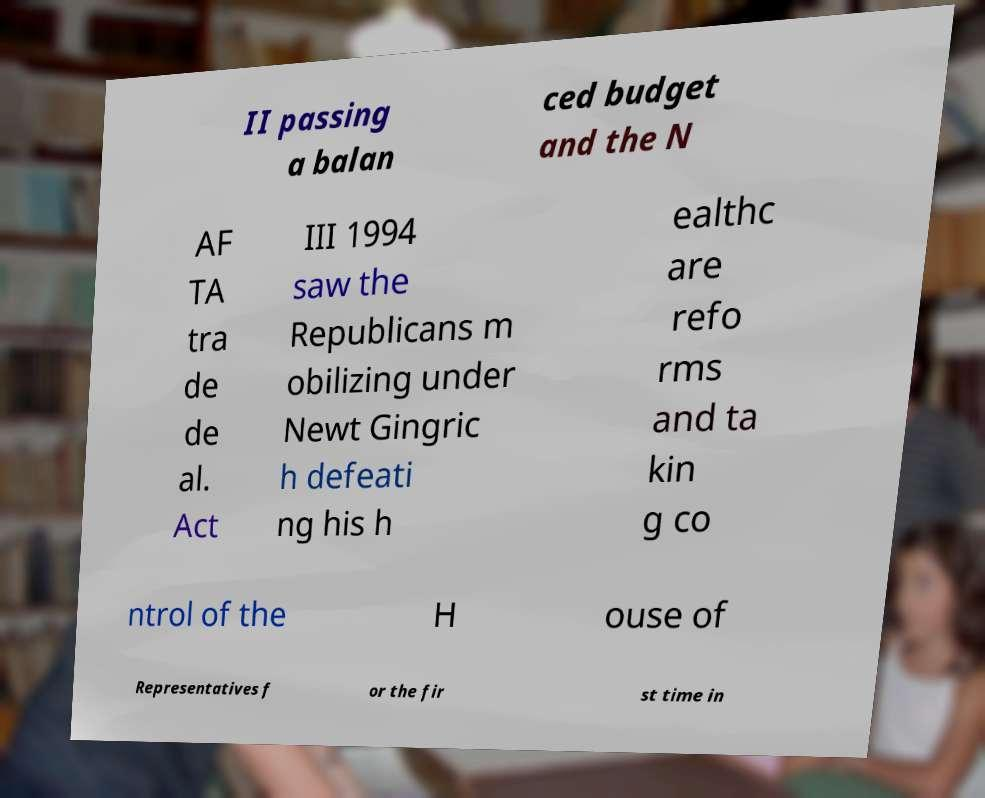I need the written content from this picture converted into text. Can you do that? II passing a balan ced budget and the N AF TA tra de de al. Act III 1994 saw the Republicans m obilizing under Newt Gingric h defeati ng his h ealthc are refo rms and ta kin g co ntrol of the H ouse of Representatives f or the fir st time in 